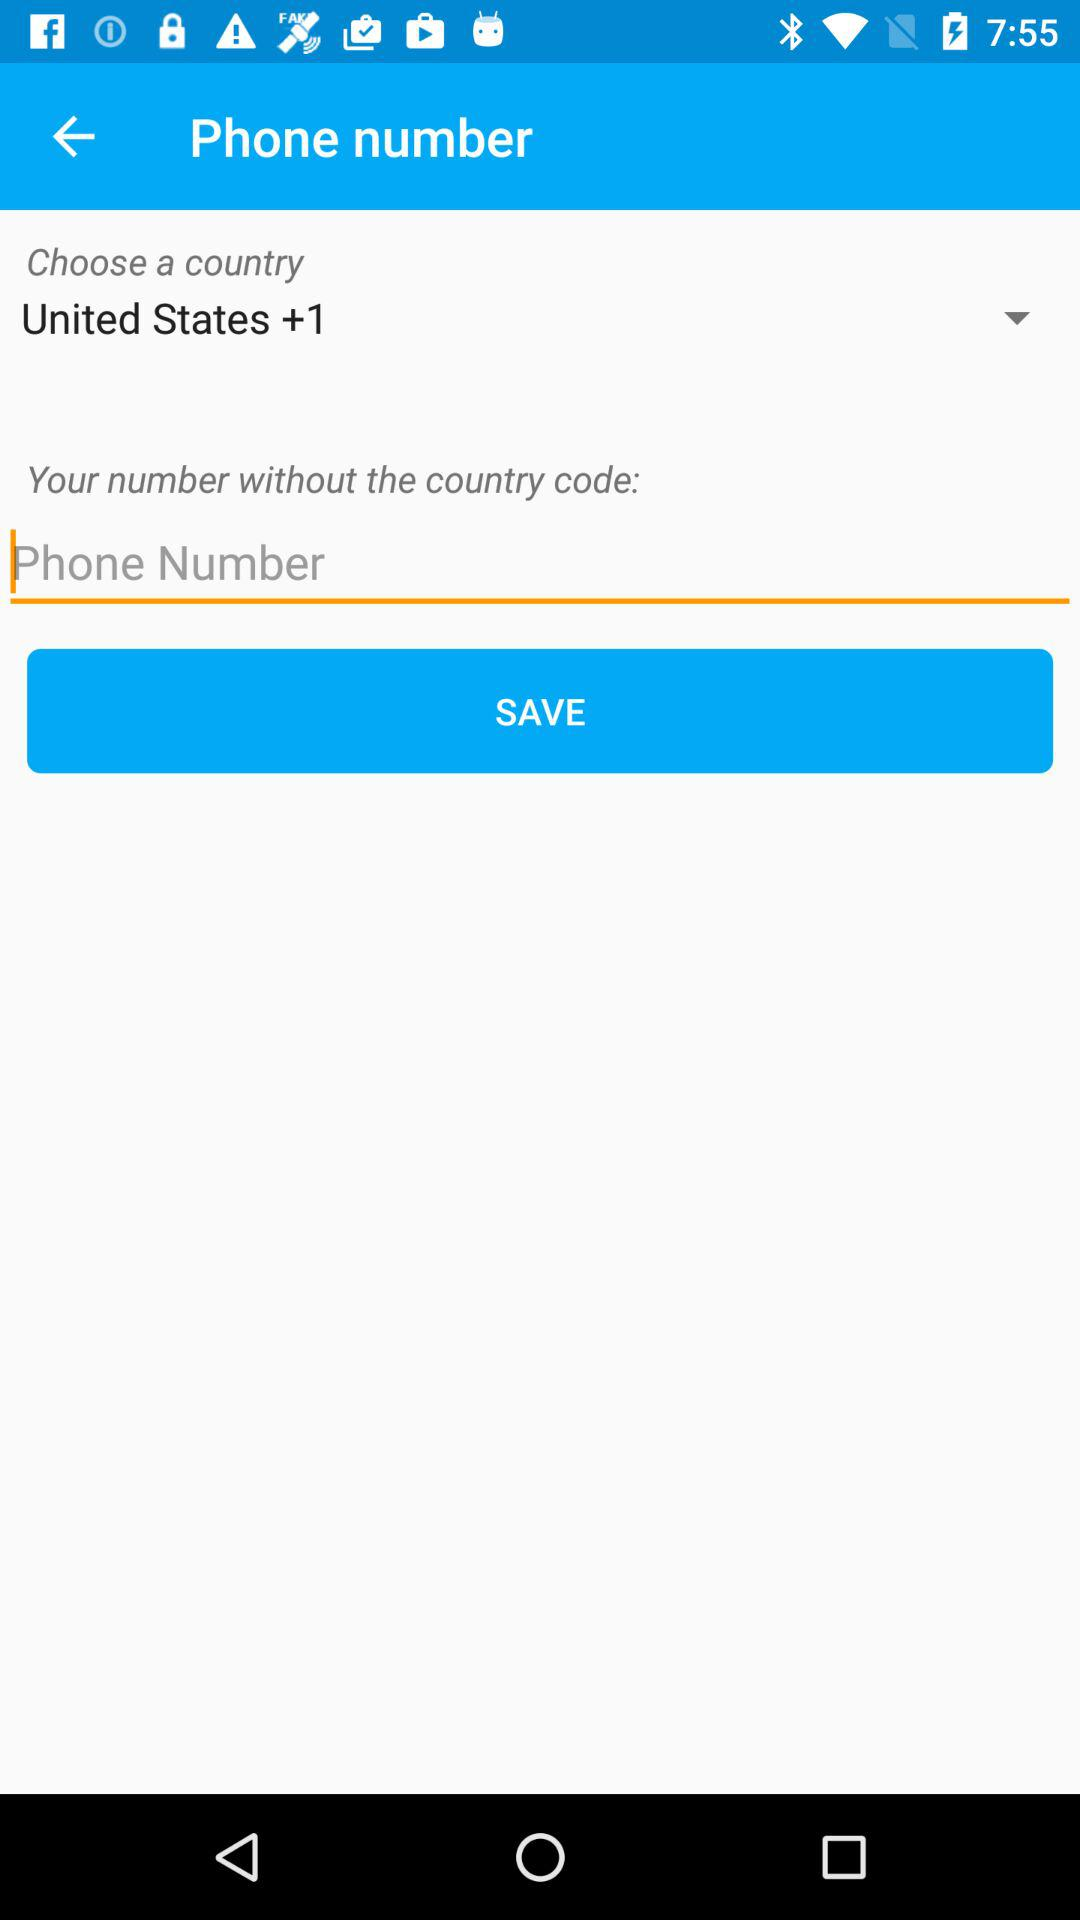Which country is selected? The selected country is the United States. 